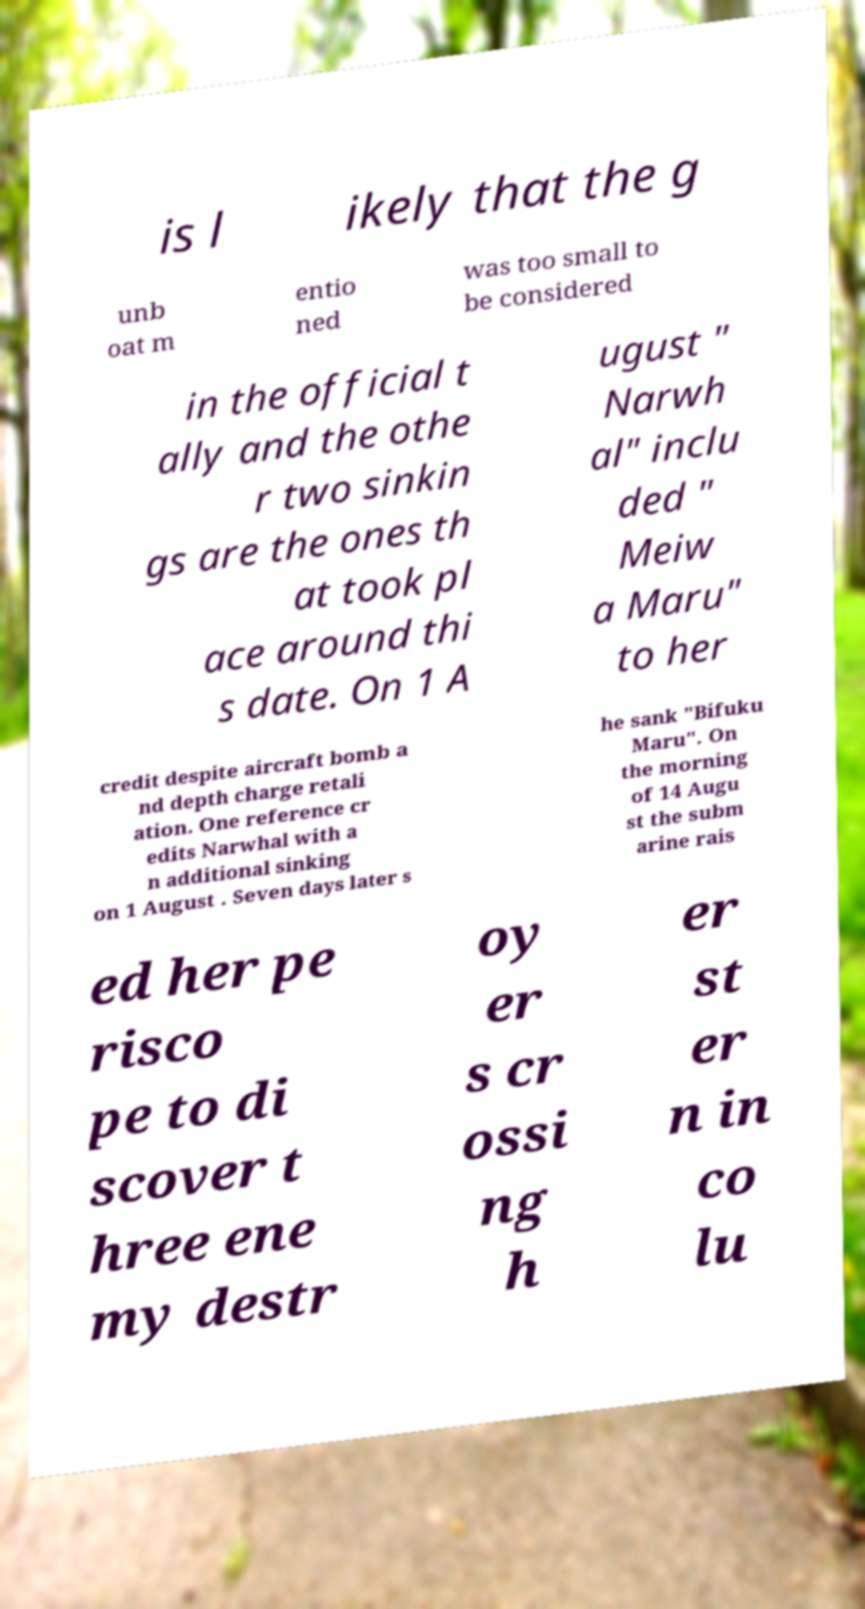I need the written content from this picture converted into text. Can you do that? is l ikely that the g unb oat m entio ned was too small to be considered in the official t ally and the othe r two sinkin gs are the ones th at took pl ace around thi s date. On 1 A ugust " Narwh al" inclu ded " Meiw a Maru" to her credit despite aircraft bomb a nd depth charge retali ation. One reference cr edits Narwhal with a n additional sinking on 1 August . Seven days later s he sank "Bifuku Maru". On the morning of 14 Augu st the subm arine rais ed her pe risco pe to di scover t hree ene my destr oy er s cr ossi ng h er st er n in co lu 